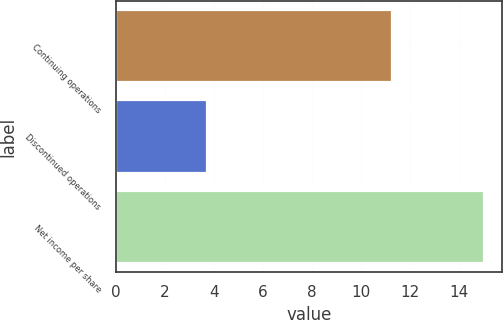<chart> <loc_0><loc_0><loc_500><loc_500><bar_chart><fcel>Continuing operations<fcel>Discontinued operations<fcel>Net income per share<nl><fcel>11.28<fcel>3.73<fcel>15.01<nl></chart> 